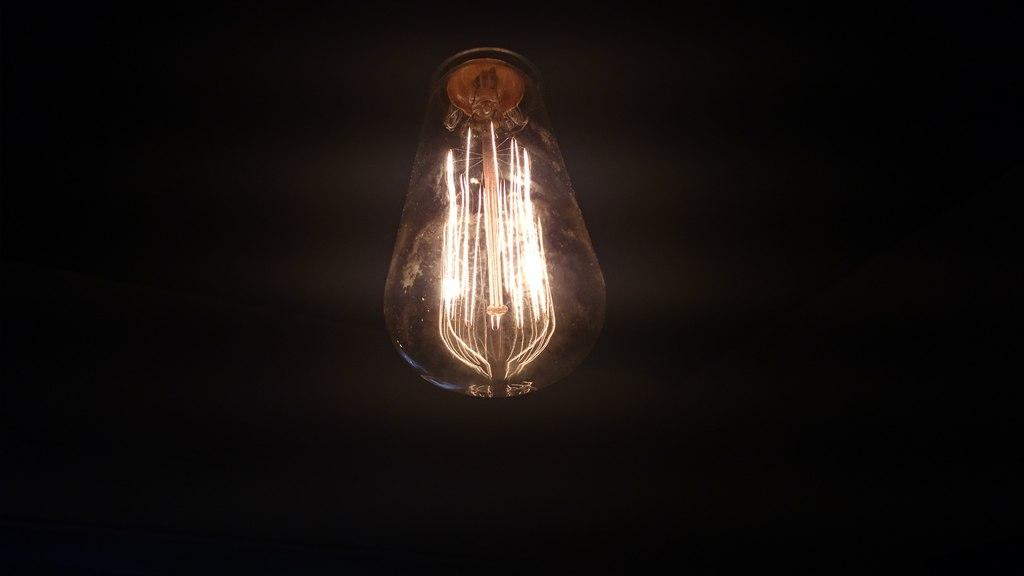What is the main object in the image? There is a bulb with a filament in the image. Can you describe the bulb's internal components? The bulb has a filament inside. What type of lighting source is depicted in the image? The image shows a traditional incandescent light bulb. What type of music can be heard playing in the background of the image? There is no music or sound present in the image, as it is a still photograph of a light bulb. 